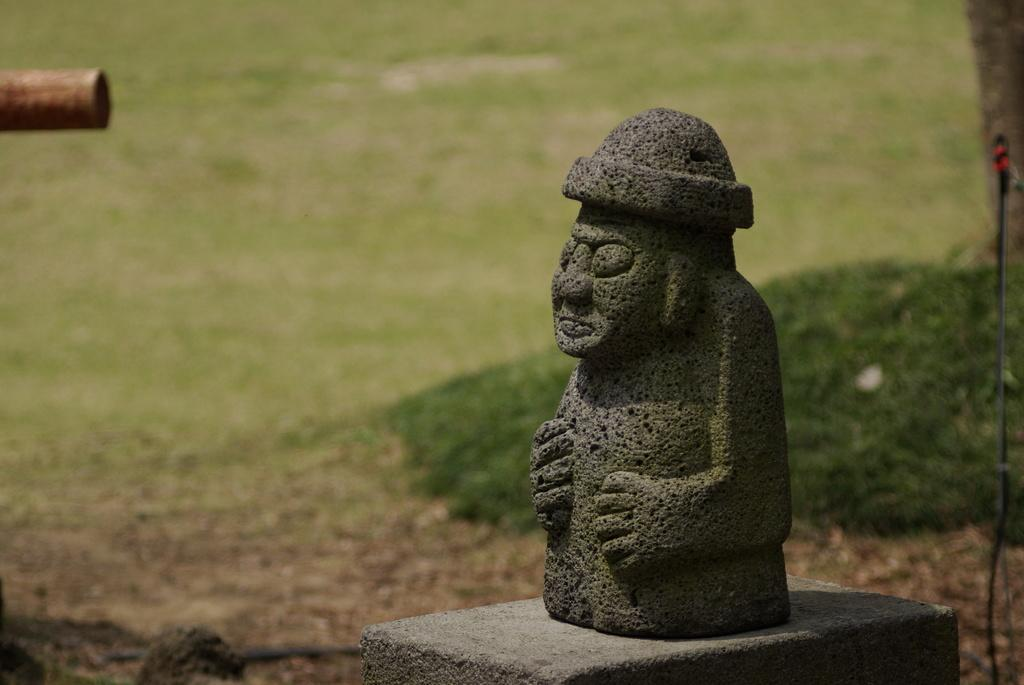What is the main subject in the image? There is a statue in the image. What type of terrain is visible in the image? There is grass and sand in the image. How many pears are on the statue in the image? There are no pears present in the image. 